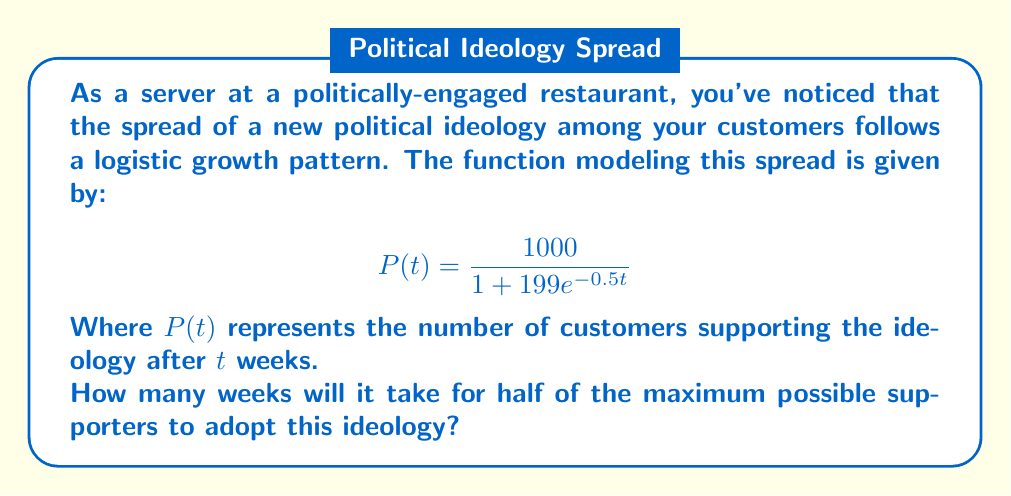Give your solution to this math problem. Let's approach this step-by-step:

1) First, we need to identify the maximum number of supporters. In a logistic function, this is the carrying capacity, which is the numerator of the fraction. Here, it's 1000.

2) We're asked to find when half of this maximum is reached. So, we're looking for $P(t) = 500$.

3) Let's set up the equation:

   $$500 = \frac{1000}{1 + 199e^{-0.5t}}$$

4) Multiply both sides by $(1 + 199e^{-0.5t})$:

   $$500(1 + 199e^{-0.5t}) = 1000$$

5) Distribute on the left side:

   $$500 + 99500e^{-0.5t} = 1000$$

6) Subtract 500 from both sides:

   $$99500e^{-0.5t} = 500$$

7) Divide both sides by 99500:

   $$e^{-0.5t} = \frac{1}{199}$$

8) Take the natural log of both sides:

   $$-0.5t = \ln(\frac{1}{199}) = -\ln(199)$$

9) Divide both sides by -0.5:

   $$t = \frac{\ln(199)}{0.5} = 2\ln(199) \approx 10.58$$

Therefore, it will take approximately 10.58 weeks for half of the maximum possible supporters to adopt this ideology.
Answer: $2\ln(199)$ weeks (≈10.58 weeks) 